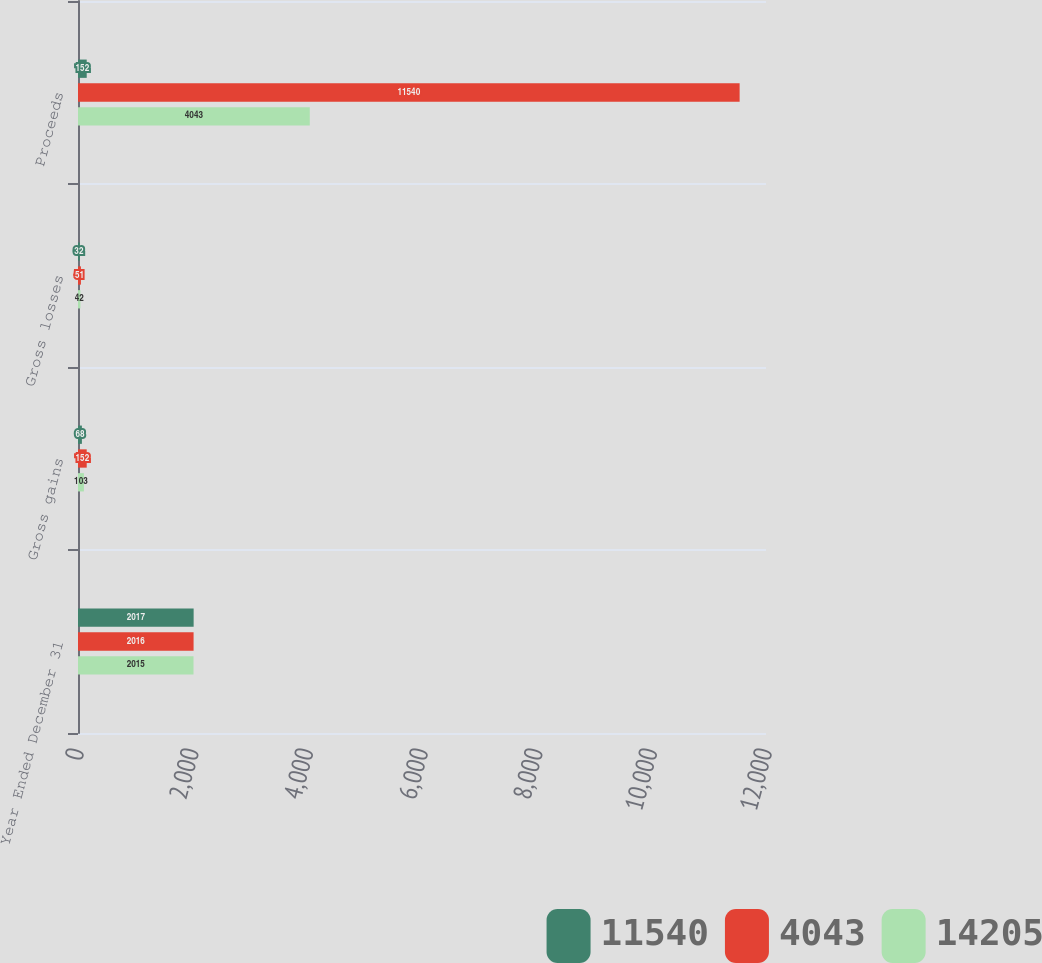Convert chart. <chart><loc_0><loc_0><loc_500><loc_500><stacked_bar_chart><ecel><fcel>Year Ended December 31<fcel>Gross gains<fcel>Gross losses<fcel>Proceeds<nl><fcel>11540<fcel>2017<fcel>68<fcel>32<fcel>152<nl><fcel>4043<fcel>2016<fcel>152<fcel>51<fcel>11540<nl><fcel>14205<fcel>2015<fcel>103<fcel>42<fcel>4043<nl></chart> 